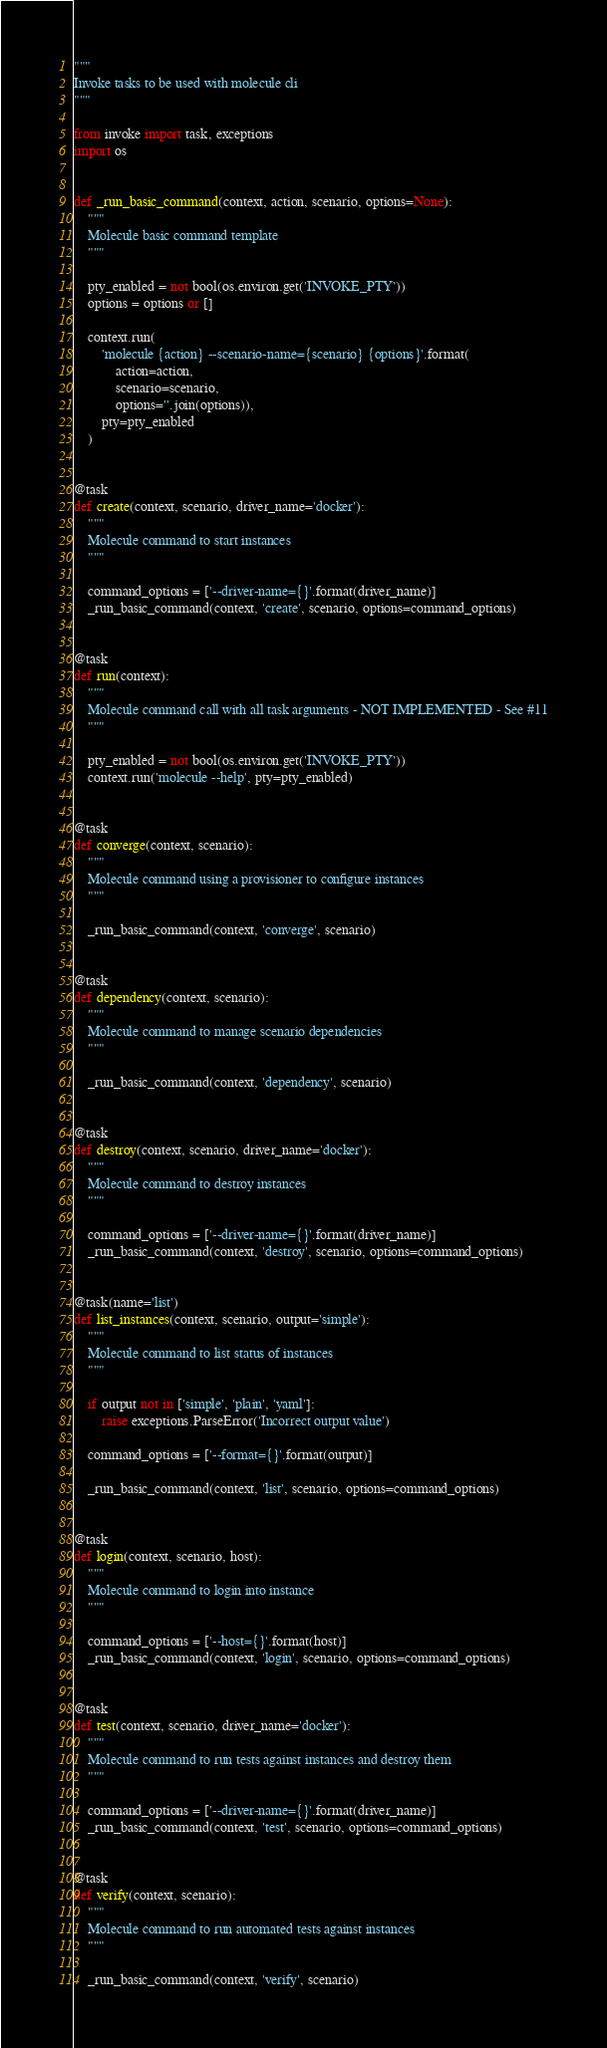Convert code to text. <code><loc_0><loc_0><loc_500><loc_500><_Python_>"""
Invoke tasks to be used with molecule cli
"""

from invoke import task, exceptions
import os


def _run_basic_command(context, action, scenario, options=None):
    """
    Molecule basic command template
    """

    pty_enabled = not bool(os.environ.get('INVOKE_PTY'))
    options = options or []

    context.run(
        'molecule {action} --scenario-name={scenario} {options}'.format(
            action=action,
            scenario=scenario,
            options=''.join(options)),
        pty=pty_enabled
    )


@task
def create(context, scenario, driver_name='docker'):
    """
    Molecule command to start instances
    """

    command_options = ['--driver-name={}'.format(driver_name)]
    _run_basic_command(context, 'create', scenario, options=command_options)


@task
def run(context):
    """
    Molecule command call with all task arguments - NOT IMPLEMENTED - See #11
    """

    pty_enabled = not bool(os.environ.get('INVOKE_PTY'))
    context.run('molecule --help', pty=pty_enabled)


@task
def converge(context, scenario):
    """
    Molecule command using a provisioner to configure instances
    """

    _run_basic_command(context, 'converge', scenario)


@task
def dependency(context, scenario):
    """
    Molecule command to manage scenario dependencies
    """

    _run_basic_command(context, 'dependency', scenario)


@task
def destroy(context, scenario, driver_name='docker'):
    """
    Molecule command to destroy instances
    """

    command_options = ['--driver-name={}'.format(driver_name)]
    _run_basic_command(context, 'destroy', scenario, options=command_options)


@task(name='list')
def list_instances(context, scenario, output='simple'):
    """
    Molecule command to list status of instances
    """

    if output not in ['simple', 'plain', 'yaml']:
        raise exceptions.ParseError('Incorrect output value')

    command_options = ['--format={}'.format(output)]

    _run_basic_command(context, 'list', scenario, options=command_options)


@task
def login(context, scenario, host):
    """
    Molecule command to login into instance
    """

    command_options = ['--host={}'.format(host)]
    _run_basic_command(context, 'login', scenario, options=command_options)


@task
def test(context, scenario, driver_name='docker'):
    """
    Molecule command to run tests against instances and destroy them
    """

    command_options = ['--driver-name={}'.format(driver_name)]
    _run_basic_command(context, 'test', scenario, options=command_options)


@task
def verify(context, scenario):
    """
    Molecule command to run automated tests against instances
    """

    _run_basic_command(context, 'verify', scenario)
</code> 